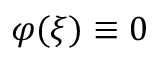Convert formula to latex. <formula><loc_0><loc_0><loc_500><loc_500>\varphi ( \xi ) \equiv 0</formula> 